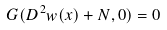Convert formula to latex. <formula><loc_0><loc_0><loc_500><loc_500>G ( D ^ { 2 } w ( x ) + N , 0 ) = 0</formula> 